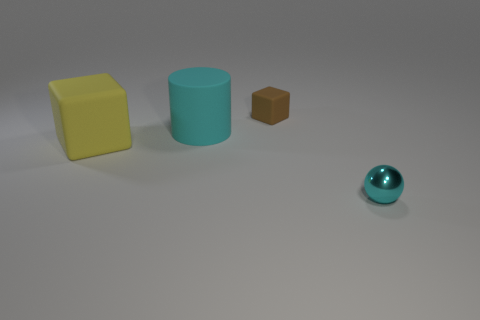Add 1 yellow rubber objects. How many objects exist? 5 Subtract all cylinders. How many objects are left? 3 Add 4 red metallic objects. How many red metallic objects exist? 4 Subtract 0 purple balls. How many objects are left? 4 Subtract all small green spheres. Subtract all large cylinders. How many objects are left? 3 Add 4 big cyan matte cylinders. How many big cyan matte cylinders are left? 5 